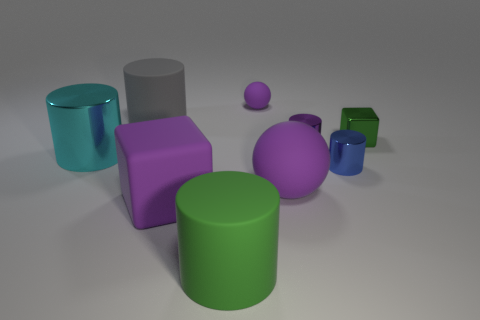Is there anything else that has the same size as the purple shiny thing?
Your response must be concise. Yes. Do the big green thing and the block to the left of the small block have the same material?
Offer a terse response. Yes. What material is the big cyan cylinder?
Provide a succinct answer. Metal. There is a block that is the same color as the big matte ball; what is its material?
Provide a succinct answer. Rubber. What number of other things are there of the same material as the tiny cube
Ensure brevity in your answer.  3. The purple rubber object that is behind the large matte cube and in front of the green metallic object has what shape?
Give a very brief answer. Sphere. What color is the big cube that is made of the same material as the large green object?
Provide a short and direct response. Purple. Are there the same number of large rubber cylinders behind the large purple cube and green matte things?
Ensure brevity in your answer.  Yes. The green thing that is the same size as the blue metallic cylinder is what shape?
Your answer should be compact. Cube. How many other objects are there of the same shape as the tiny green thing?
Your answer should be compact. 1. 